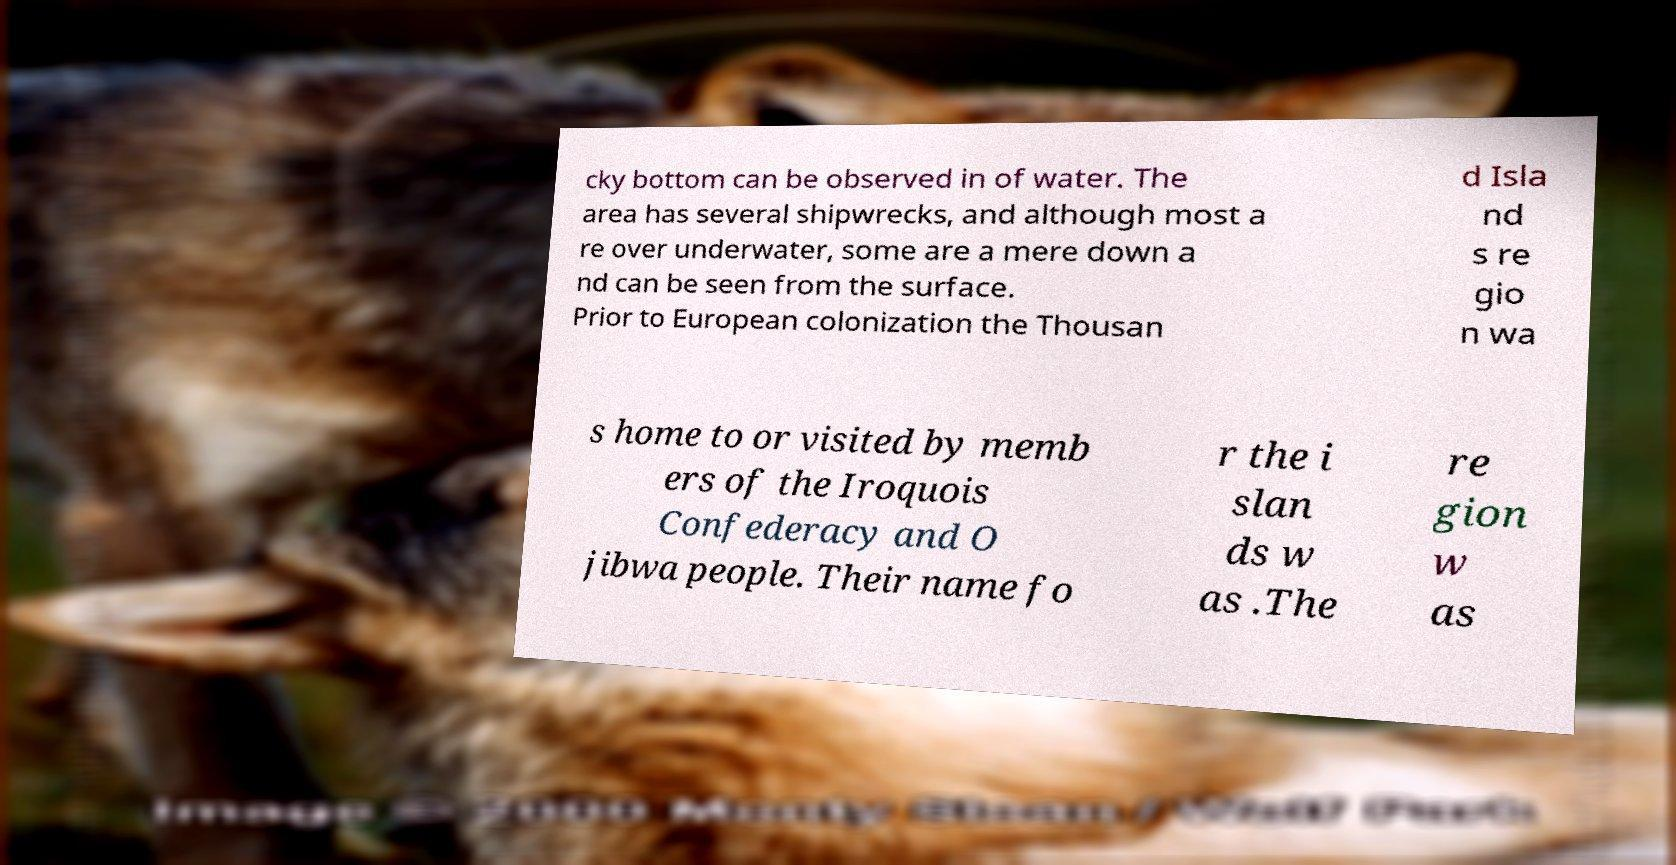Can you accurately transcribe the text from the provided image for me? cky bottom can be observed in of water. The area has several shipwrecks, and although most a re over underwater, some are a mere down a nd can be seen from the surface. Prior to European colonization the Thousan d Isla nd s re gio n wa s home to or visited by memb ers of the Iroquois Confederacy and O jibwa people. Their name fo r the i slan ds w as .The re gion w as 